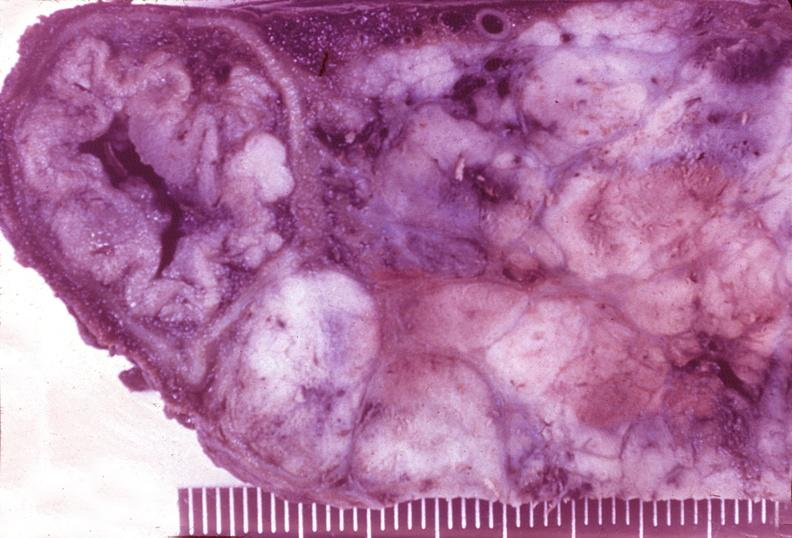what does this image show?
Answer the question using a single word or phrase. Islet cell carcinoma 